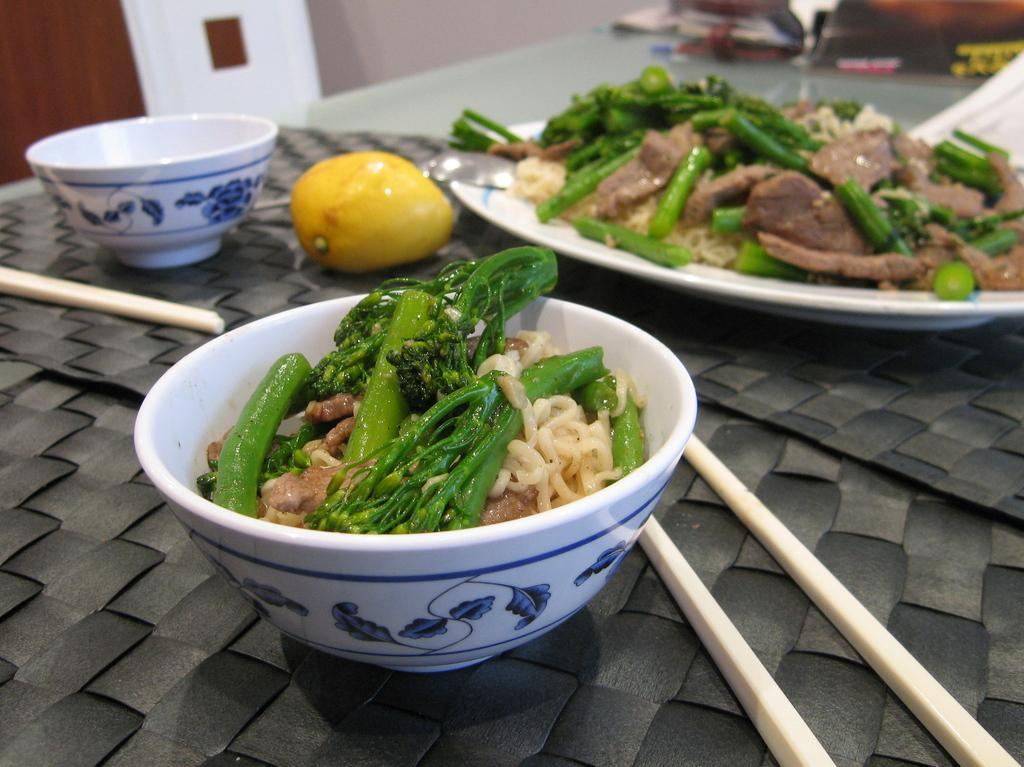What type of utensils can be seen in the image? Chopsticks are visible in the image. What is the primary object on which food items are placed? There is a plate in the image, and food items are present on it. What type of container is used to hold food items in the image? There are bowls in the image, and food items are in one of them. What is the fruit placed on in the image? The fruit is on a black object. Are there any other objects visible in the image besides the food items? Yes, there are objects at the top of the image. What type of background can be seen in the image? There is a wall visible in the image. How many parcels are being delivered in the image? There are no parcels visible in the image. Can you describe the group of people gathered around the table in the image? There is no group of people gathered around a table in the image. What type of vegetation is present in the image? There is no mention of vegetation or bushes in the image. 